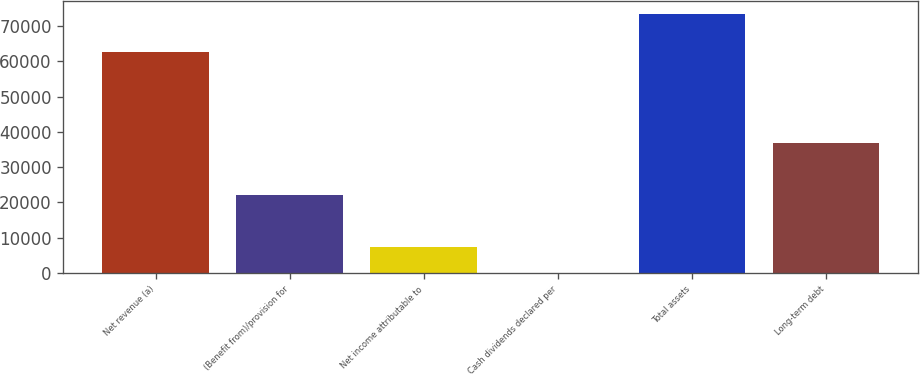Convert chart to OTSL. <chart><loc_0><loc_0><loc_500><loc_500><bar_chart><fcel>Net revenue (a)<fcel>(Benefit from)/provision for<fcel>Net income attributable to<fcel>Cash dividends declared per<fcel>Total assets<fcel>Long-term debt<nl><fcel>62799<fcel>22049.1<fcel>7351.66<fcel>2.96<fcel>73490<fcel>36746.5<nl></chart> 